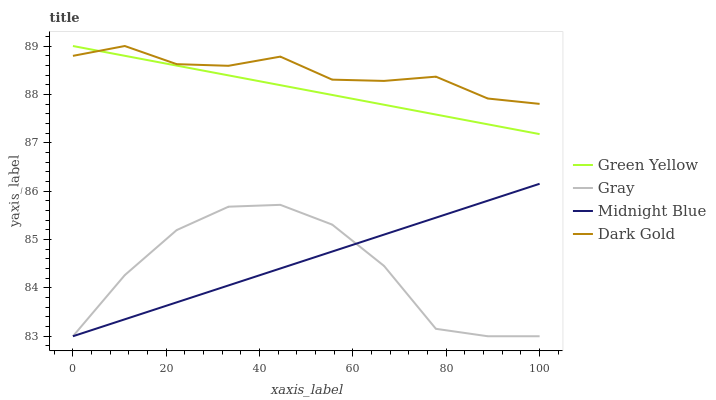Does Gray have the minimum area under the curve?
Answer yes or no. Yes. Does Dark Gold have the maximum area under the curve?
Answer yes or no. Yes. Does Green Yellow have the minimum area under the curve?
Answer yes or no. No. Does Green Yellow have the maximum area under the curve?
Answer yes or no. No. Is Midnight Blue the smoothest?
Answer yes or no. Yes. Is Gray the roughest?
Answer yes or no. Yes. Is Green Yellow the smoothest?
Answer yes or no. No. Is Green Yellow the roughest?
Answer yes or no. No. Does Green Yellow have the lowest value?
Answer yes or no. No. Does Dark Gold have the highest value?
Answer yes or no. Yes. Does Midnight Blue have the highest value?
Answer yes or no. No. Is Gray less than Dark Gold?
Answer yes or no. Yes. Is Green Yellow greater than Gray?
Answer yes or no. Yes. Does Green Yellow intersect Dark Gold?
Answer yes or no. Yes. Is Green Yellow less than Dark Gold?
Answer yes or no. No. Is Green Yellow greater than Dark Gold?
Answer yes or no. No. Does Gray intersect Dark Gold?
Answer yes or no. No. 